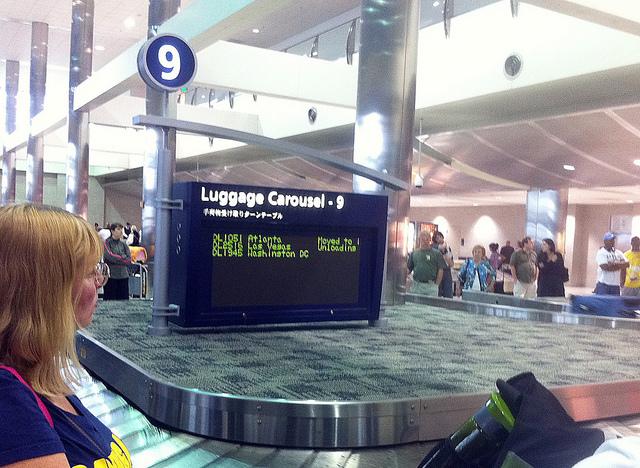What doe the screen say?
Short answer required. Luggage carousel. What number is above the screen?
Write a very short answer. 9. What part of the airport is this?
Be succinct. Baggage claim. 